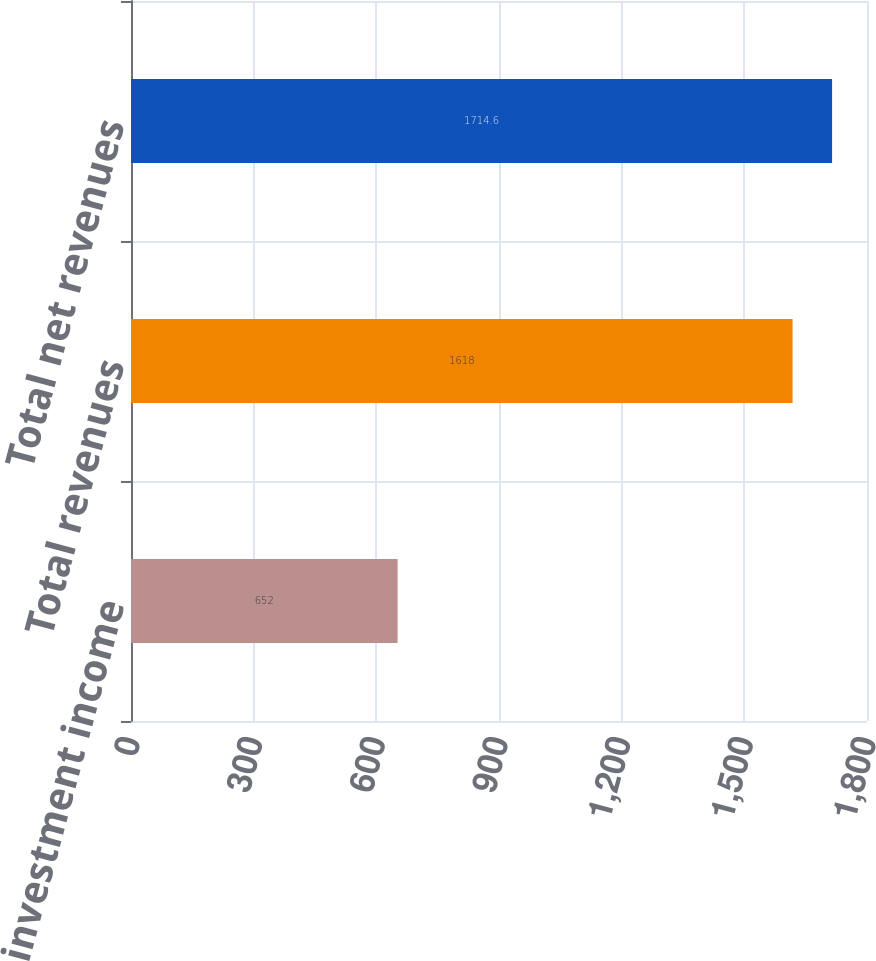Convert chart to OTSL. <chart><loc_0><loc_0><loc_500><loc_500><bar_chart><fcel>Net investment income<fcel>Total revenues<fcel>Total net revenues<nl><fcel>652<fcel>1618<fcel>1714.6<nl></chart> 